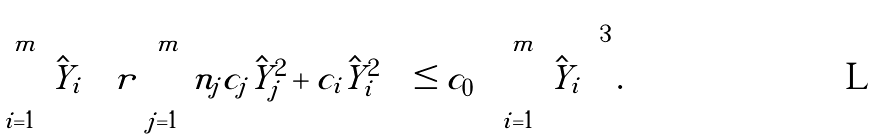Convert formula to latex. <formula><loc_0><loc_0><loc_500><loc_500>\sum _ { i = 1 } ^ { m } \hat { Y } _ { i } \left ( r \sum _ { j = 1 } ^ { m } n _ { j } c _ { j } \hat { Y } _ { j } ^ { 2 } + c _ { i } \hat { Y } _ { i } ^ { 2 } \right ) \leq c _ { 0 } \left ( \sum _ { i = 1 } ^ { m } \hat { Y } _ { i } \right ) ^ { 3 } .</formula> 